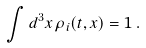Convert formula to latex. <formula><loc_0><loc_0><loc_500><loc_500>\int d ^ { 3 } { x } \, \rho _ { i } ( t , { x } ) = 1 \, .</formula> 